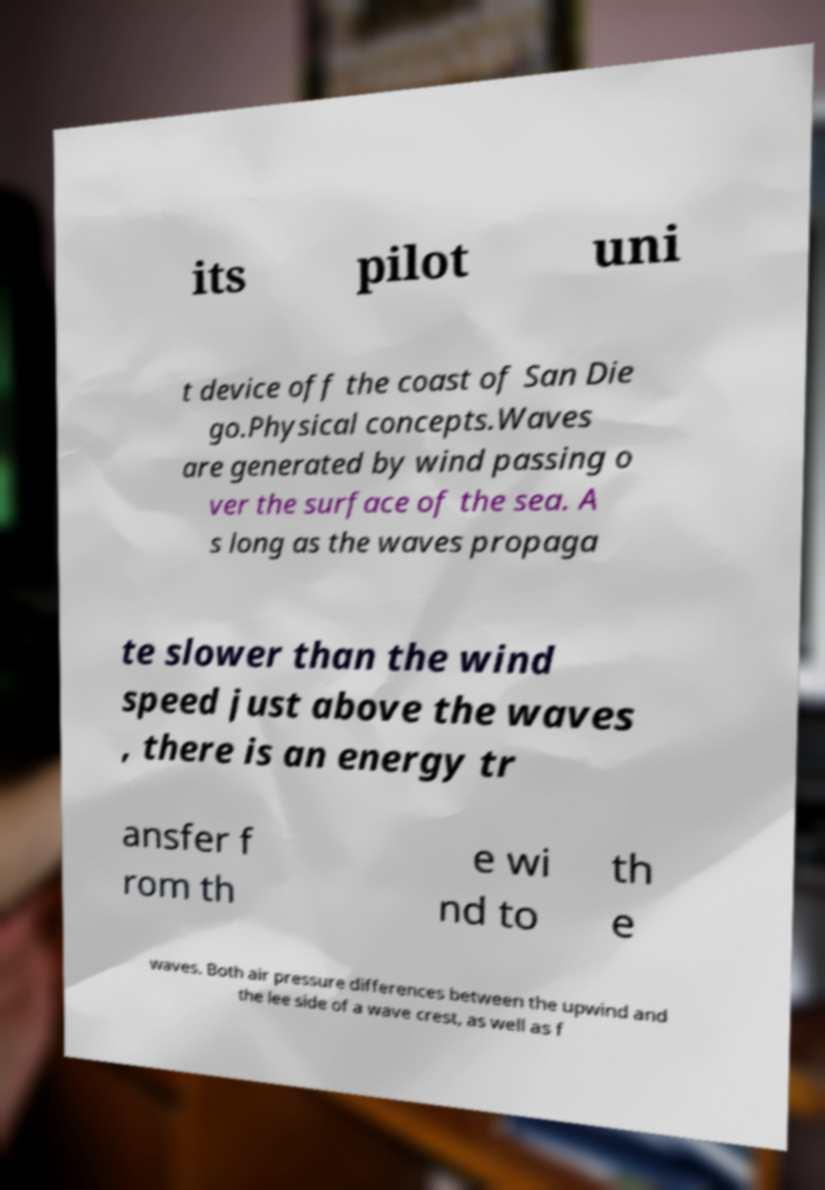Could you assist in decoding the text presented in this image and type it out clearly? its pilot uni t device off the coast of San Die go.Physical concepts.Waves are generated by wind passing o ver the surface of the sea. A s long as the waves propaga te slower than the wind speed just above the waves , there is an energy tr ansfer f rom th e wi nd to th e waves. Both air pressure differences between the upwind and the lee side of a wave crest, as well as f 